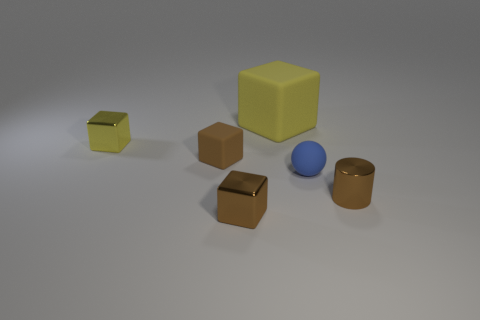Add 1 tiny gray shiny cylinders. How many objects exist? 7 Subtract all balls. How many objects are left? 5 Add 2 blue matte things. How many blue matte things exist? 3 Subtract all yellow cubes. How many cubes are left? 2 Subtract all small brown shiny blocks. How many blocks are left? 3 Subtract 0 red cylinders. How many objects are left? 6 Subtract 1 cylinders. How many cylinders are left? 0 Subtract all red cylinders. Subtract all purple cubes. How many cylinders are left? 1 Subtract all red cylinders. How many yellow cubes are left? 2 Subtract all tiny metal cylinders. Subtract all brown metallic things. How many objects are left? 3 